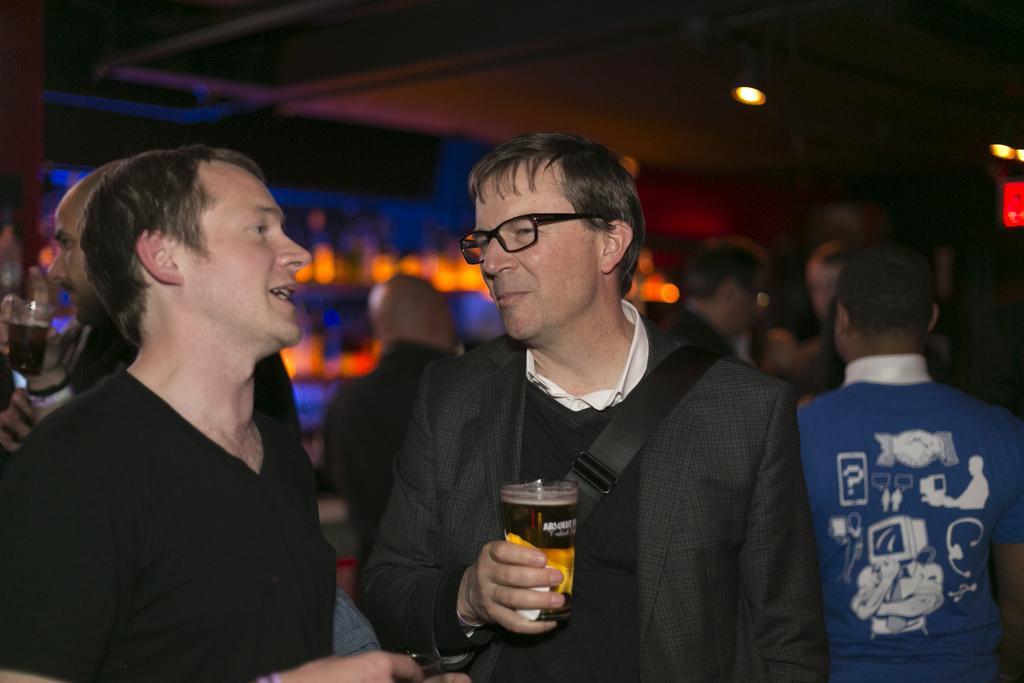In one or two sentences, can you explain what this image depicts? As we can see in the image there are few people standing. The person who is standing in the middle is wearing spectacles and holding glass in his hand. 